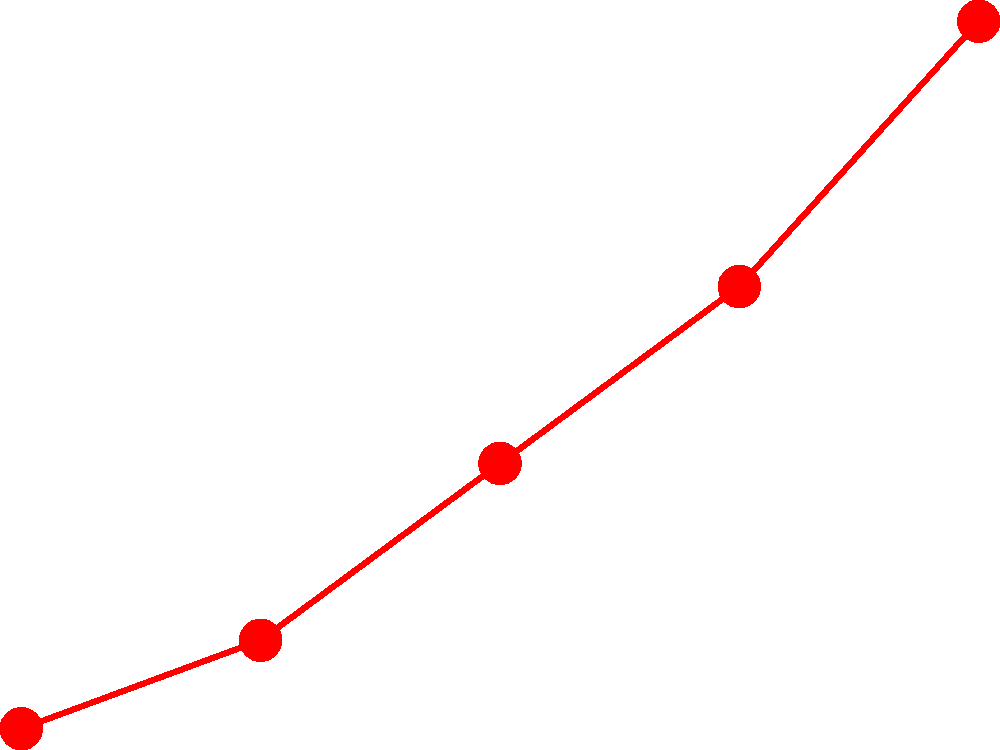Based on the bar graph, what is the approximate percentage increase in burnout rate when the weekly workload increases from 50 to 55 hours? To solve this problem, we need to follow these steps:

1. Identify the burnout rates for 50 and 55 weekly hours:
   - At 50 hours: approximately 35%
   - At 55 hours: approximately 45%

2. Calculate the difference in burnout rates:
   45% - 35% = 10%

3. Calculate the percentage increase:
   (Increase / Original Value) * 100
   = (10 / 35) * 100
   ≈ 28.57%

Therefore, the burnout rate increases by approximately 28.57% when the weekly workload increases from 50 to 55 hours.
Answer: 28.57% 